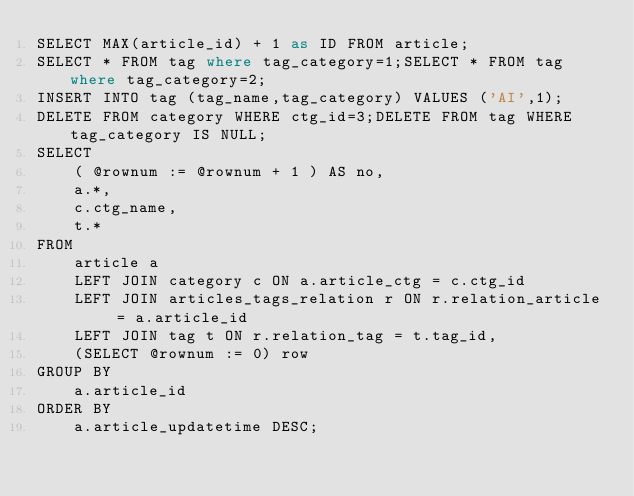<code> <loc_0><loc_0><loc_500><loc_500><_SQL_>SELECT MAX(article_id) + 1 as ID FROM article;
SELECT * FROM tag where tag_category=1;SELECT * FROM tag where tag_category=2;
INSERT INTO tag (tag_name,tag_category) VALUES ('AI',1);
DELETE FROM category WHERE ctg_id=3;DELETE FROM tag WHERE tag_category IS NULL;
SELECT
	( @rownum := @rownum + 1 ) AS no,
	a.*,
	c.ctg_name,
	t.*
FROM
	article a
	LEFT JOIN category c ON a.article_ctg = c.ctg_id
	LEFT JOIN articles_tags_relation r ON r.relation_article = a.article_id
	LEFT JOIN tag t ON r.relation_tag = t.tag_id,
	(SELECT @rownum := 0) row
GROUP BY
	a.article_id
ORDER BY
	a.article_updatetime DESC;
</code> 